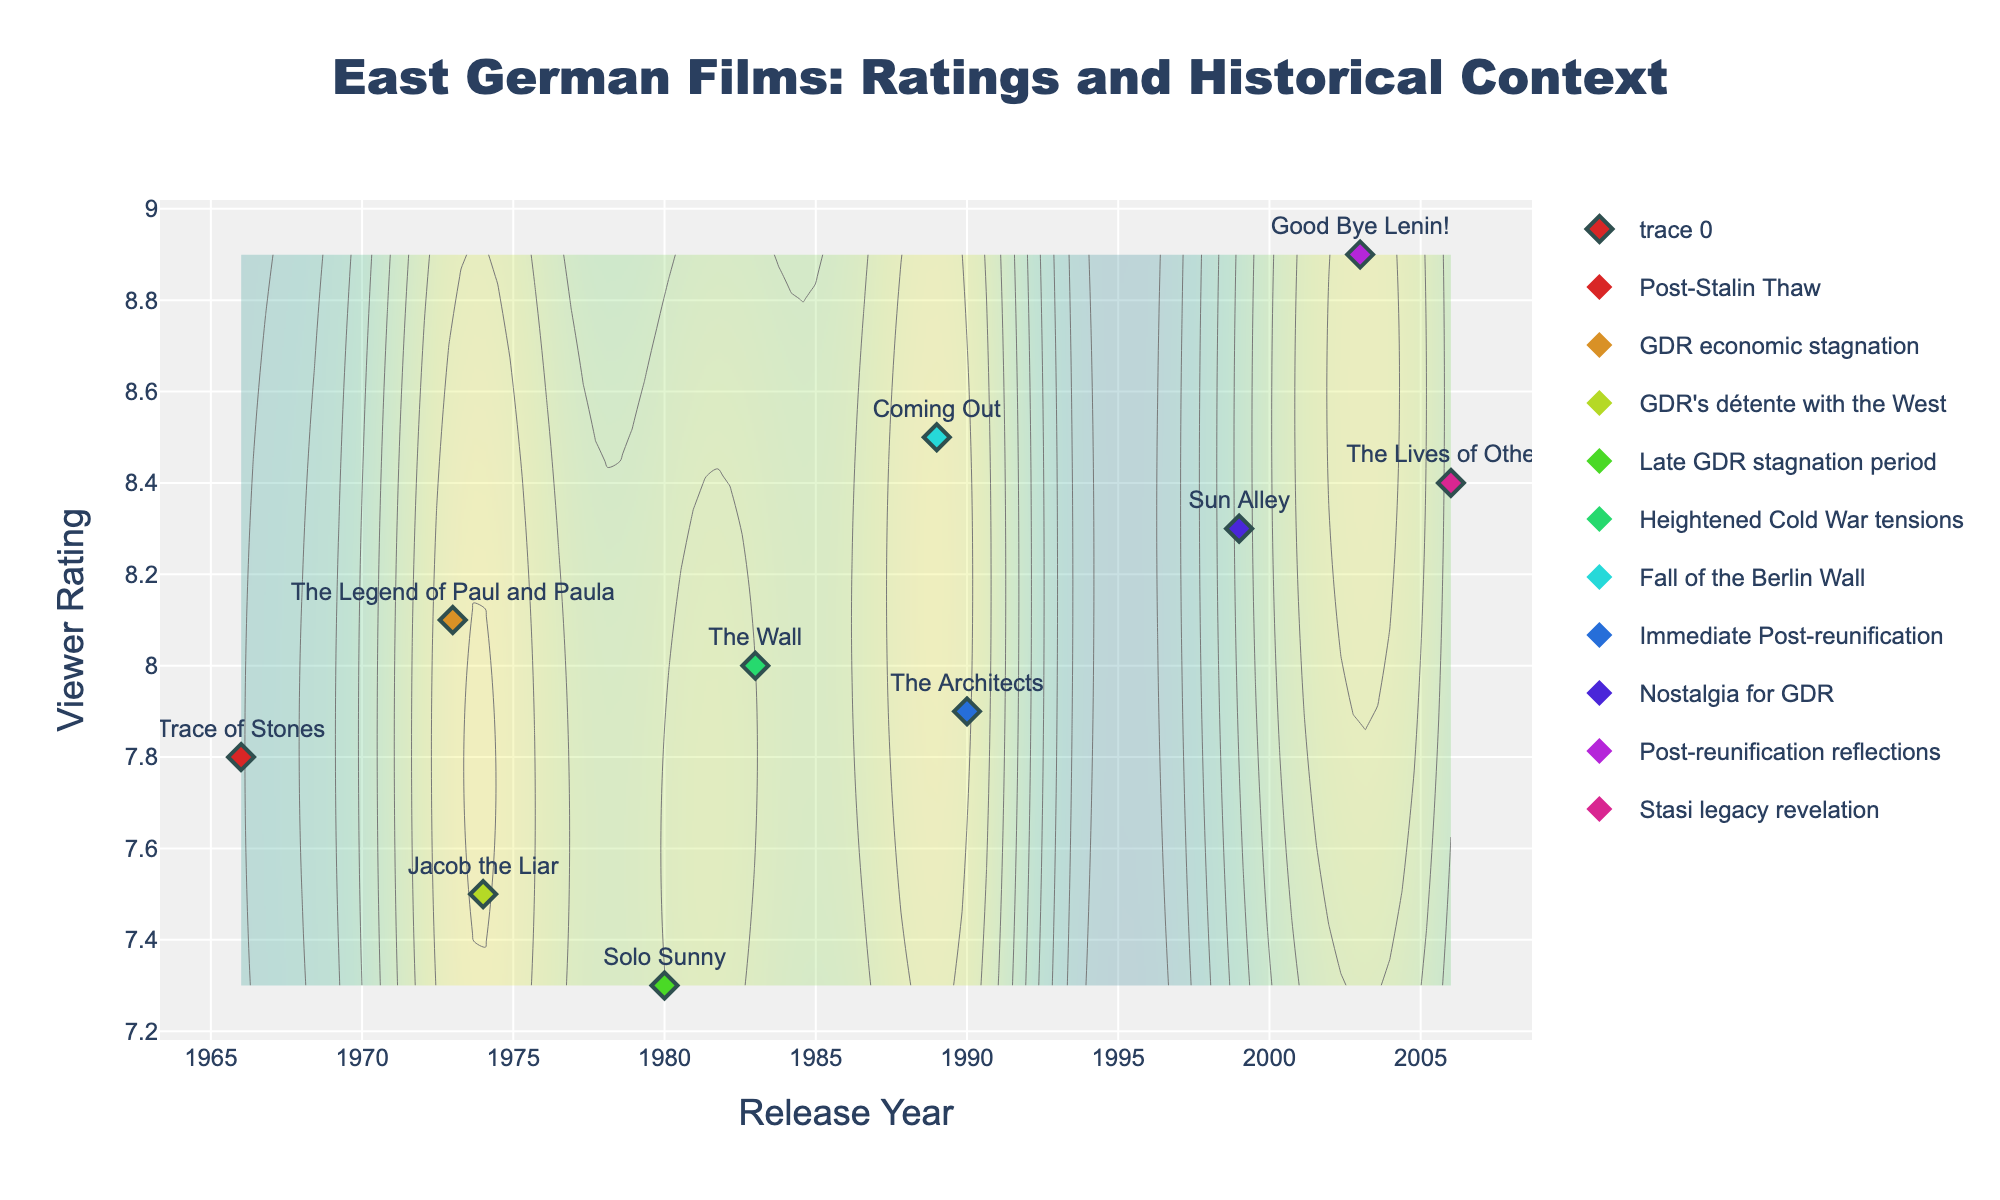What is the title of the plot? The plot title is located at the top center of the figure. It gives the main description of what the plot is about, which is regarding the ratings of East German films in the context of historical events.
Answer: East German Films: Ratings and Historical Context What is the highest viewer rating in the plot and for which film was it given? Check the y-axis for the highest value, and the corresponding data point's label indicates the film. The highest rating is marked on the plot for the corresponding film.
Answer: Good Bye Lenin! Which historical event has the highest rated film associated with it? Identify the highest viewer rating on the y-axis and check the label and the color coding of the data point, matching it with the event in the legend.
Answer: Post-reunification reflections How many films were released between 1970 and 1990? Look for data points between the years 1970 and 1990 on the x-axis and count them.
Answer: Six Which film has the lowest viewer rating? Find the lowest point on the y-axis and identify the corresponding film label on that data point.
Answer: Solo Sunny What is the average viewer rating of films released after the fall of the Berlin Wall? Identify films released from 1989 onwards, find their ratings, sum them up, and divide by the number of these films (three films: Coming Out, The Architects, Good Bye Lenin!). Calculate the average rating. (8.5+7.9+8.9)/3 = 25.3/3 = 8.43.
Answer: 8.43 Compare the viewer ratings of "The Legend of Paul and Paula" and "Jacob the Liar." Which one has higher ratings? Identify the points for both films, check their ratings via y-axis, and compare these values. "The Legend of Paul and Paula" has a higher rating than "Jacob the Liar".
Answer: The Legend of Paul and Paula Which historical event corresponds to the film with the lowest rating? Identify the lowest rating on the y-axis, note the corresponding film and its event color from the legend. The film "Solo Sunny" corresponds to the event "Late GDR stagnation period".
Answer: Late GDR stagnation period What is the median viewer rating of all films? Organize the films' ratings in ascending order and find the middle value. The ratings are 7.3, 7.5, 7.8, 7.9, 8.0, 8.1, 8.3, 8.4, 8.5, 8.9, so the median (middle) rating is (8.0 + 8.1) / 2 = 8.05.
Answer: 8.05 How does the contour indicate regions of higher film density? The contour plot uses colors to indicate density, with warmer colors (closer to yellow) representing higher density regions, indicating more films with similar release years and ratings.
Answer: Warmer colors (yellow regions) indicate higher density regions 